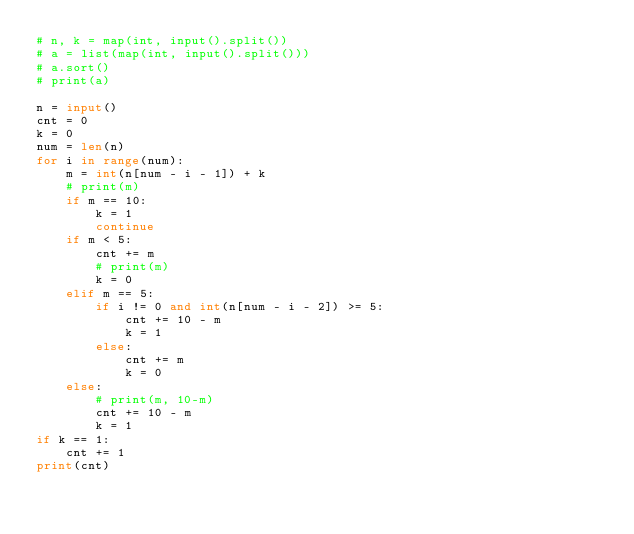Convert code to text. <code><loc_0><loc_0><loc_500><loc_500><_Python_># n, k = map(int, input().split())
# a = list(map(int, input().split()))
# a.sort()
# print(a)

n = input()
cnt = 0
k = 0
num = len(n)
for i in range(num):
    m = int(n[num - i - 1]) + k
    # print(m)
    if m == 10:
        k = 1
        continue
    if m < 5:
        cnt += m
        # print(m)
        k = 0
    elif m == 5:
        if i != 0 and int(n[num - i - 2]) >= 5:
            cnt += 10 - m
            k = 1
        else:
            cnt += m
            k = 0
    else:
        # print(m, 10-m)
        cnt += 10 - m
        k = 1
if k == 1:
    cnt += 1
print(cnt)</code> 